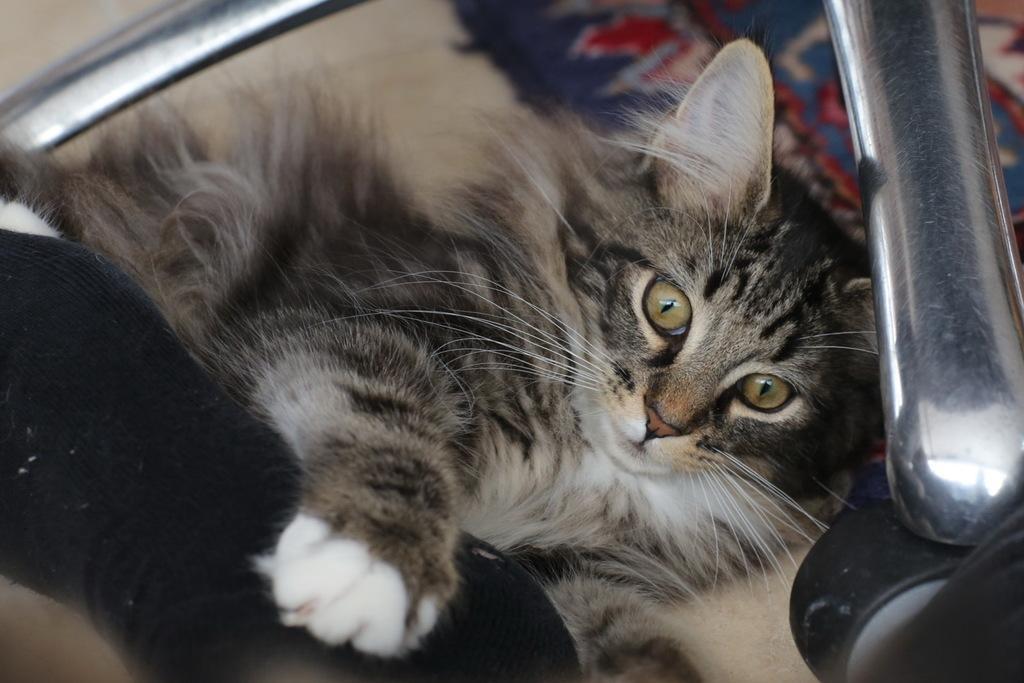Describe this image in one or two sentences. In this image we can see one carpet on the floor, one cat and some objects on the floor. 